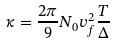Convert formula to latex. <formula><loc_0><loc_0><loc_500><loc_500>\kappa = \frac { 2 \pi } { 9 } N _ { 0 } v _ { f } ^ { 2 } \frac { T } { \Delta } \,</formula> 